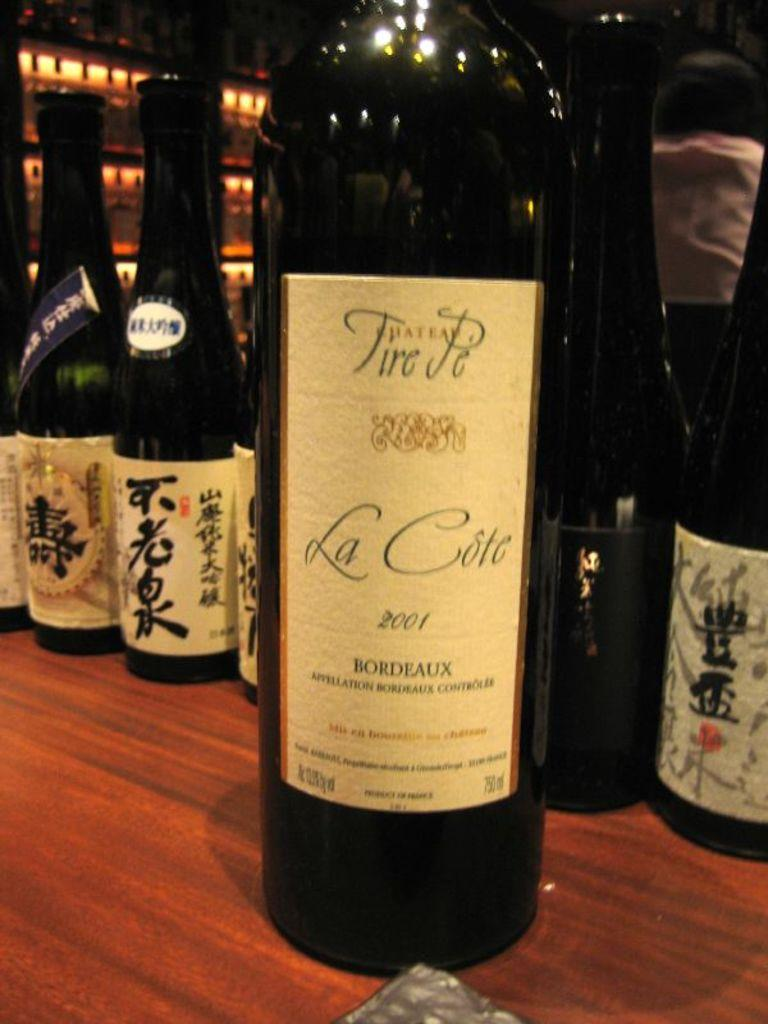<image>
Share a concise interpretation of the image provided. A wine bottle with the label Chateau Tire Pe, La Cote  2001 Bordeaux on a wood table with other bottles behind it. 